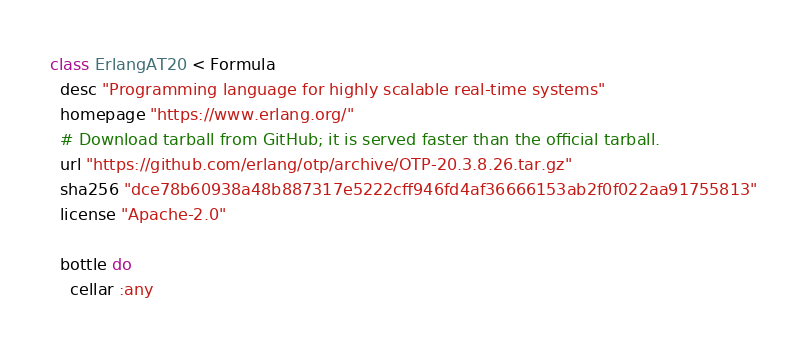<code> <loc_0><loc_0><loc_500><loc_500><_Ruby_>class ErlangAT20 < Formula
  desc "Programming language for highly scalable real-time systems"
  homepage "https://www.erlang.org/"
  # Download tarball from GitHub; it is served faster than the official tarball.
  url "https://github.com/erlang/otp/archive/OTP-20.3.8.26.tar.gz"
  sha256 "dce78b60938a48b887317e5222cff946fd4af36666153ab2f0f022aa91755813"
  license "Apache-2.0"

  bottle do
    cellar :any</code> 